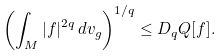<formula> <loc_0><loc_0><loc_500><loc_500>\left ( \int _ { M } | f | ^ { 2 q } \, d v _ { g } \right ) ^ { 1 / q } \leq D _ { q } Q [ f ] .</formula> 